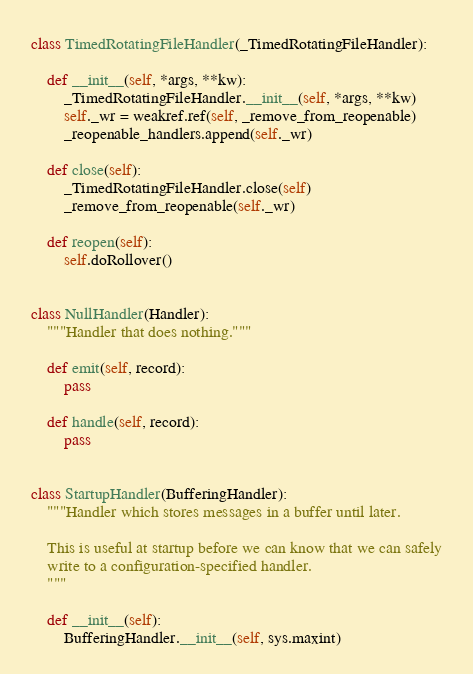<code> <loc_0><loc_0><loc_500><loc_500><_Python_>class TimedRotatingFileHandler(_TimedRotatingFileHandler):

    def __init__(self, *args, **kw):
        _TimedRotatingFileHandler.__init__(self, *args, **kw)
        self._wr = weakref.ref(self, _remove_from_reopenable)
        _reopenable_handlers.append(self._wr)

    def close(self):
        _TimedRotatingFileHandler.close(self)
        _remove_from_reopenable(self._wr)

    def reopen(self):
        self.doRollover()


class NullHandler(Handler):
    """Handler that does nothing."""

    def emit(self, record):
        pass

    def handle(self, record):
        pass


class StartupHandler(BufferingHandler):
    """Handler which stores messages in a buffer until later.

    This is useful at startup before we can know that we can safely
    write to a configuration-specified handler.
    """

    def __init__(self):
        BufferingHandler.__init__(self, sys.maxint)
</code> 